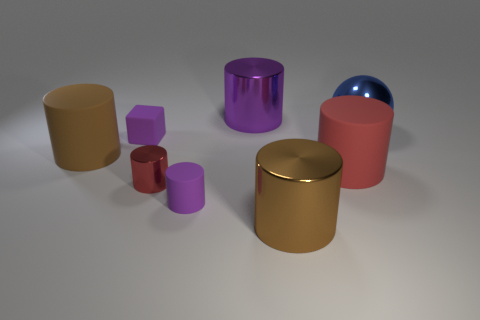Subtract all blue blocks. How many brown cylinders are left? 2 Add 1 tiny red things. How many objects exist? 9 Subtract all red cylinders. How many cylinders are left? 4 Subtract all brown cylinders. How many cylinders are left? 4 Subtract all blue cylinders. Subtract all gray cubes. How many cylinders are left? 6 Subtract all balls. How many objects are left? 7 Add 1 large blue spheres. How many large blue spheres are left? 2 Add 1 tiny red cylinders. How many tiny red cylinders exist? 2 Subtract 0 cyan cylinders. How many objects are left? 8 Subtract all big shiny spheres. Subtract all large brown cylinders. How many objects are left? 5 